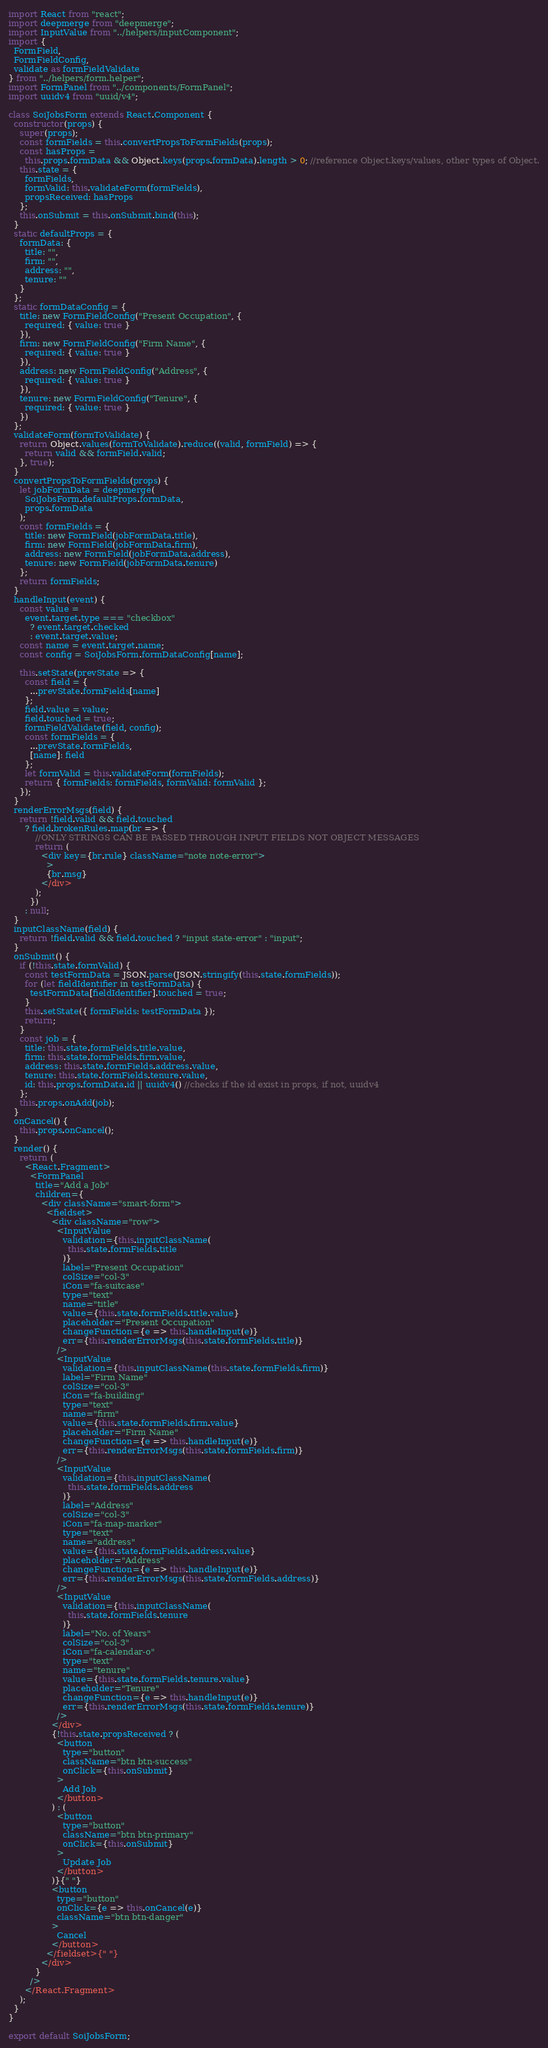Convert code to text. <code><loc_0><loc_0><loc_500><loc_500><_JavaScript_>import React from "react";
import deepmerge from "deepmerge";
import InputValue from "../helpers/inputComponent";
import {
  FormField,
  FormFieldConfig,
  validate as formFieldValidate
} from "../helpers/form.helper";
import FormPanel from "../components/FormPanel";
import uuidv4 from "uuid/v4";

class SoiJobsForm extends React.Component {
  constructor(props) {
    super(props);
    const formFields = this.convertPropsToFormFields(props);
    const hasProps =
      this.props.formData && Object.keys(props.formData).length > 0; //reference Object.keys/values, other types of Object.
    this.state = {
      formFields,
      formValid: this.validateForm(formFields),
      propsReceived: hasProps
    };
    this.onSubmit = this.onSubmit.bind(this);
  }
  static defaultProps = {
    formData: {
      title: "",
      firm: "",
      address: "",
      tenure: ""
    }
  };
  static formDataConfig = {
    title: new FormFieldConfig("Present Occupation", {
      required: { value: true }
    }),
    firm: new FormFieldConfig("Firm Name", {
      required: { value: true }
    }),
    address: new FormFieldConfig("Address", {
      required: { value: true }
    }),
    tenure: new FormFieldConfig("Tenure", {
      required: { value: true }
    })
  };
  validateForm(formToValidate) {
    return Object.values(formToValidate).reduce((valid, formField) => {
      return valid && formField.valid;
    }, true);
  }
  convertPropsToFormFields(props) {
    let jobFormData = deepmerge(
      SoiJobsForm.defaultProps.formData,
      props.formData
    );
    const formFields = {
      title: new FormField(jobFormData.title),
      firm: new FormField(jobFormData.firm),
      address: new FormField(jobFormData.address),
      tenure: new FormField(jobFormData.tenure)
    };
    return formFields;
  }
  handleInput(event) {
    const value =
      event.target.type === "checkbox"
        ? event.target.checked
        : event.target.value;
    const name = event.target.name;
    const config = SoiJobsForm.formDataConfig[name];

    this.setState(prevState => {
      const field = {
        ...prevState.formFields[name]
      };
      field.value = value;
      field.touched = true;
      formFieldValidate(field, config);
      const formFields = {
        ...prevState.formFields,
        [name]: field
      };
      let formValid = this.validateForm(formFields);
      return { formFields: formFields, formValid: formValid };
    });
  }
  renderErrorMsgs(field) {
    return !field.valid && field.touched
      ? field.brokenRules.map(br => {
          //ONLY STRINGS CAN BE PASSED THROUGH INPUT FIELDS NOT OBJECT MESSAGES
          return (
            <div key={br.rule} className="note note-error">
              >
              {br.msg}
            </div>
          );
        })
      : null;
  }
  inputClassName(field) {
    return !field.valid && field.touched ? "input state-error" : "input";
  }
  onSubmit() {
    if (!this.state.formValid) {
      const testFormData = JSON.parse(JSON.stringify(this.state.formFields));
      for (let fieldIdentifier in testFormData) {
        testFormData[fieldIdentifier].touched = true;
      }
      this.setState({ formFields: testFormData });
      return;
    }
    const job = {
      title: this.state.formFields.title.value,
      firm: this.state.formFields.firm.value,
      address: this.state.formFields.address.value,
      tenure: this.state.formFields.tenure.value,
      id: this.props.formData.id || uuidv4() //checks if the id exist in props, if not, uuidv4
    };
    this.props.onAdd(job);
  }
  onCancel() {
    this.props.onCancel();
  }
  render() {
    return (
      <React.Fragment>
        <FormPanel
          title="Add a Job"
          children={
            <div className="smart-form">
              <fieldset>
                <div className="row">
                  <InputValue
                    validation={this.inputClassName(
                      this.state.formFields.title
                    )}
                    label="Present Occupation"
                    colSize="col-3"
                    iCon="fa-suitcase"
                    type="text"
                    name="title"
                    value={this.state.formFields.title.value}
                    placeholder="Present Occupation"
                    changeFunction={e => this.handleInput(e)}
                    err={this.renderErrorMsgs(this.state.formFields.title)}
                  />
                  <InputValue
                    validation={this.inputClassName(this.state.formFields.firm)}
                    label="Firm Name"
                    colSize="col-3"
                    iCon="fa-building"
                    type="text"
                    name="firm"
                    value={this.state.formFields.firm.value}
                    placeholder="Firm Name"
                    changeFunction={e => this.handleInput(e)}
                    err={this.renderErrorMsgs(this.state.formFields.firm)}
                  />
                  <InputValue
                    validation={this.inputClassName(
                      this.state.formFields.address
                    )}
                    label="Address"
                    colSize="col-3"
                    iCon="fa-map-marker"
                    type="text"
                    name="address"
                    value={this.state.formFields.address.value}
                    placeholder="Address"
                    changeFunction={e => this.handleInput(e)}
                    err={this.renderErrorMsgs(this.state.formFields.address)}
                  />
                  <InputValue
                    validation={this.inputClassName(
                      this.state.formFields.tenure
                    )}
                    label="No. of Years"
                    colSize="col-3"
                    iCon="fa-calendar-o"
                    type="text"
                    name="tenure"
                    value={this.state.formFields.tenure.value}
                    placeholder="Tenure"
                    changeFunction={e => this.handleInput(e)}
                    err={this.renderErrorMsgs(this.state.formFields.tenure)}
                  />
                </div>
                {!this.state.propsReceived ? (
                  <button
                    type="button"
                    className="btn btn-success"
                    onClick={this.onSubmit}
                  >
                    Add Job
                  </button>
                ) : (
                  <button
                    type="button"
                    className="btn btn-primary"
                    onClick={this.onSubmit}
                  >
                    Update Job
                  </button>
                )}{" "}
                <button
                  type="button"
                  onClick={e => this.onCancel(e)}
                  className="btn btn-danger"
                >
                  Cancel
                </button>
              </fieldset>{" "}
            </div>
          }
        />
      </React.Fragment>
    );
  }
}

export default SoiJobsForm;
</code> 